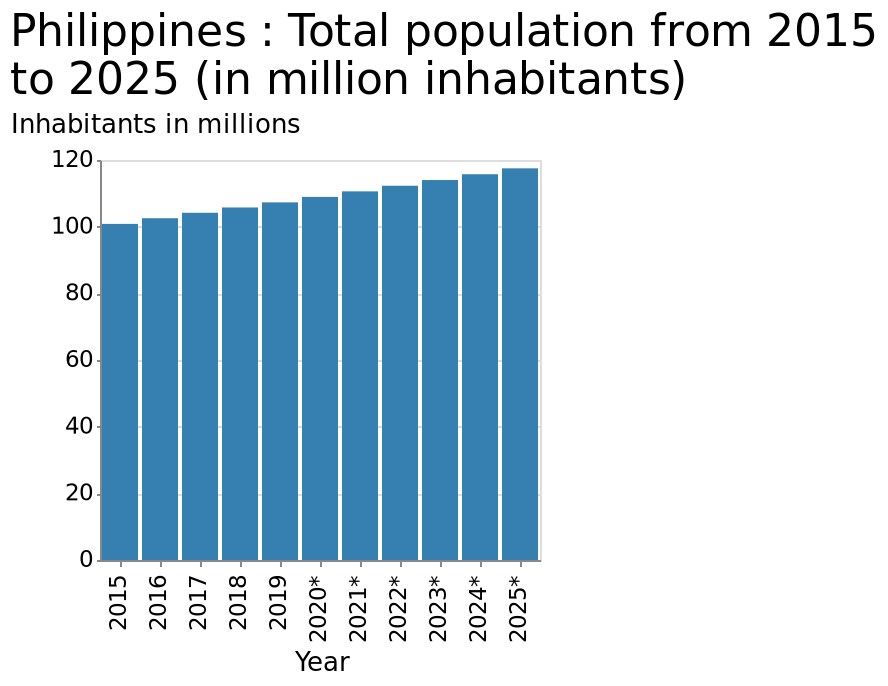<image>
What is the predicted population of the Philippines by 2025?  The predicted population of the Philippines by 2025 is nearing 119 million. What is the minimum value on the y-axis? The minimum value on the y-axis is 0 inhabitants in millions. What is the maximum value on the y-axis? The maximum value on the y-axis is 120 inhabitants in millions. 